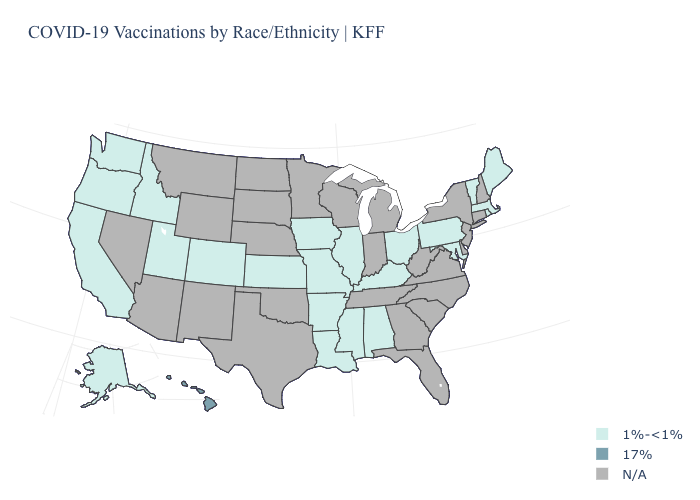What is the value of Massachusetts?
Be succinct. 1%-<1%. Name the states that have a value in the range 17%?
Write a very short answer. Hawaii. What is the value of New York?
Give a very brief answer. N/A. What is the value of Montana?
Concise answer only. N/A. What is the value of Utah?
Short answer required. 1%-<1%. What is the value of Oklahoma?
Write a very short answer. N/A. What is the value of Kentucky?
Keep it brief. 1%-<1%. What is the lowest value in states that border Nebraska?
Short answer required. 1%-<1%. Name the states that have a value in the range 17%?
Keep it brief. Hawaii. Does the map have missing data?
Short answer required. Yes. 